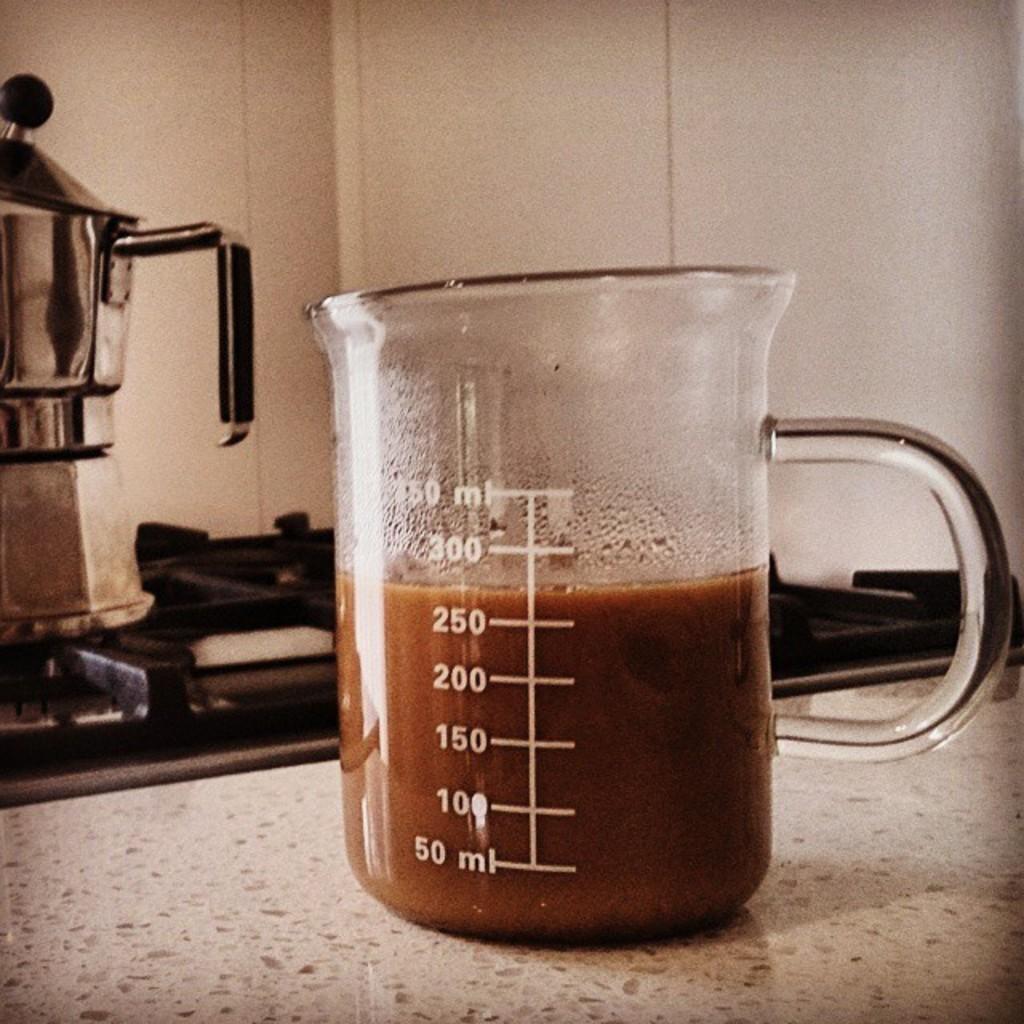How full is this cup?
Your response must be concise. 275 ml. What is the lowest ml?
Ensure brevity in your answer.  50. 